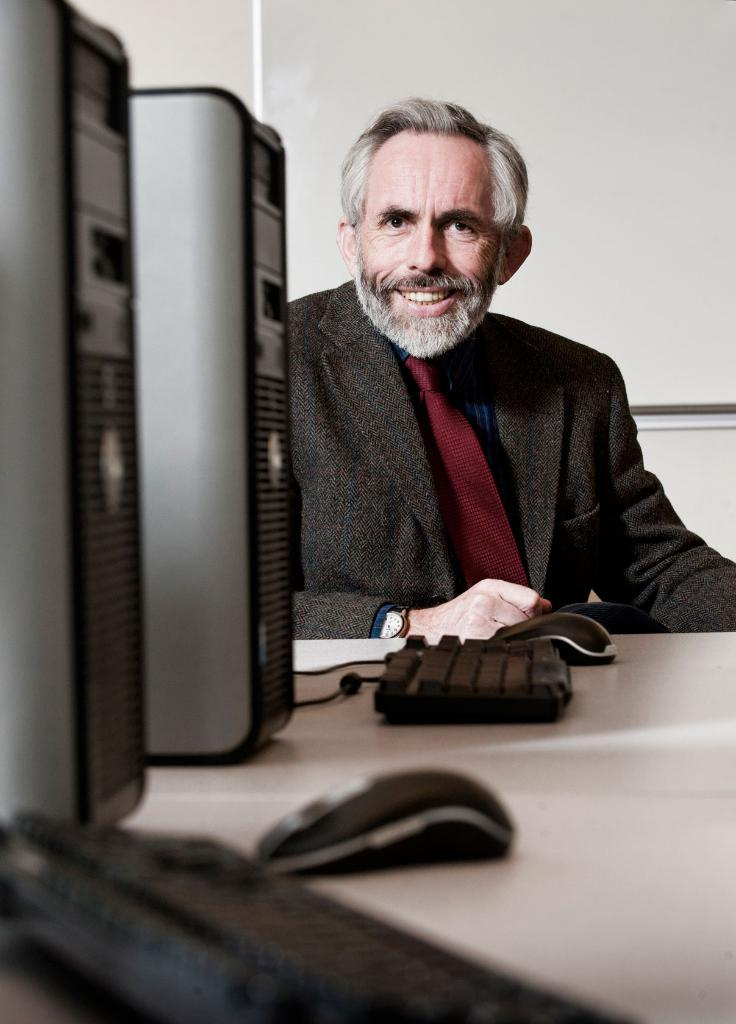What is the main piece of furniture in the image? There is a table in the image. What electronic devices are on the table? There are two PCs, two keyboards, and two mouses on the table. Who is present in the image? There is a man in the image. What is the man wearing? The man is wearing a suit and tie, and he is also wearing a watch. What is the man's facial expression? The man is smiling. What type of jelly is the man eating in the image? There is no jelly present in the image; the man is not eating anything. What language is the man speaking in the image? There is no indication of the man speaking in the image, so it cannot be determined what language he might be using. 